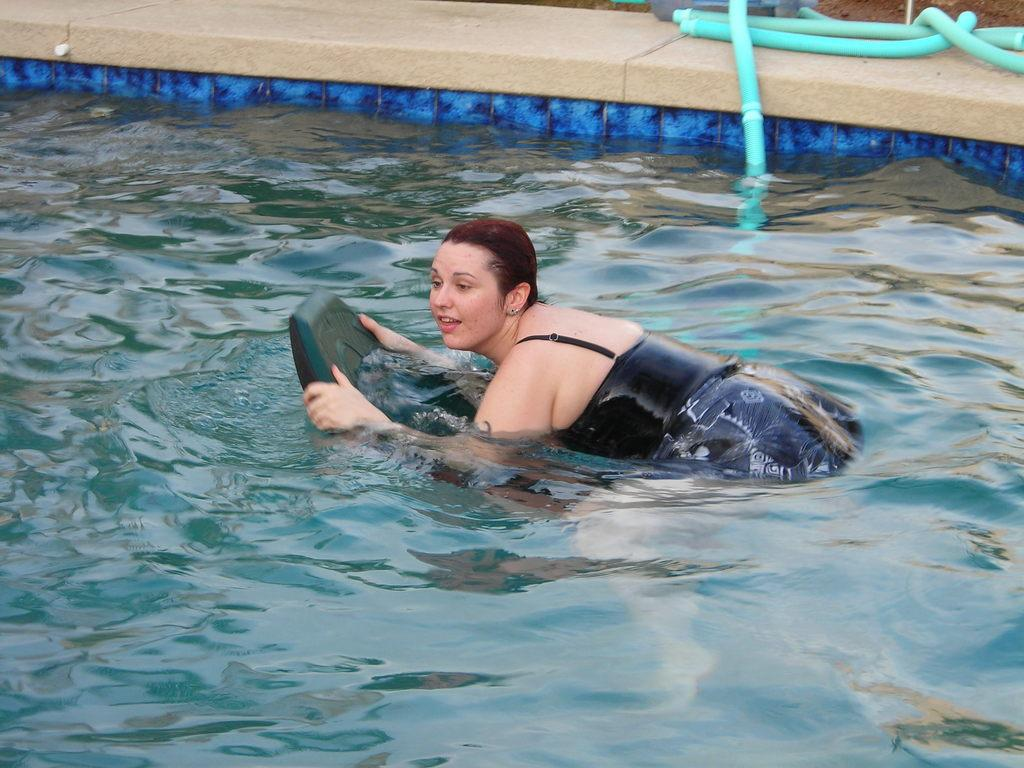What is located at the bottom of the image? There is a pool at the bottom of the image. What is the woman in the image doing? A woman is swimming in the pool. What is the woman holding while swimming? The woman is holding an object while swimming. What can be seen in the background of the image? There is a pipe visible in the background of the image. What type of competition is taking place in the image? There is no competition present in the image; it simply shows a woman swimming in a pool. How does the woman's digestion affect her swimming in the image? There is no information about the woman's digestion in the image, and it does not affect her swimming. 